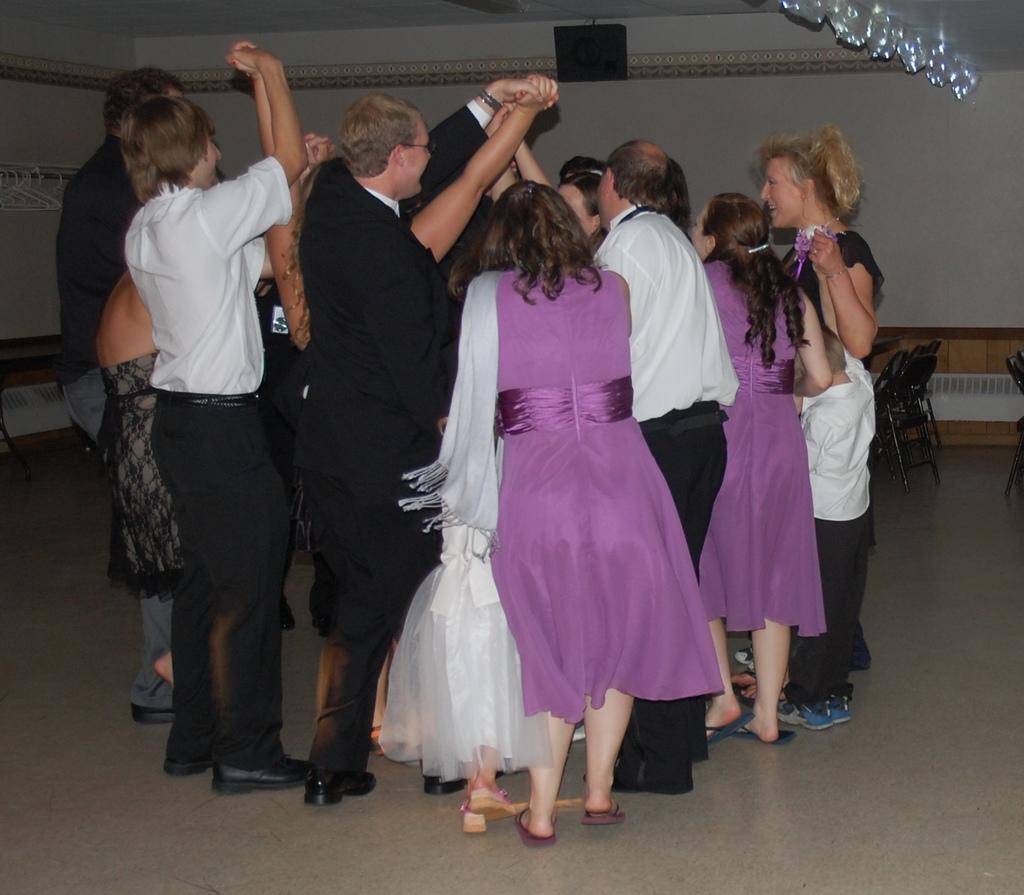Can you describe this image briefly? In the center of the image there is a person wearing black color suit and besides him there is a lady wearing a purple color dress and there are many people in center dancing. At the background of the image there is wall. At the right side corner of the image there are chairs. 